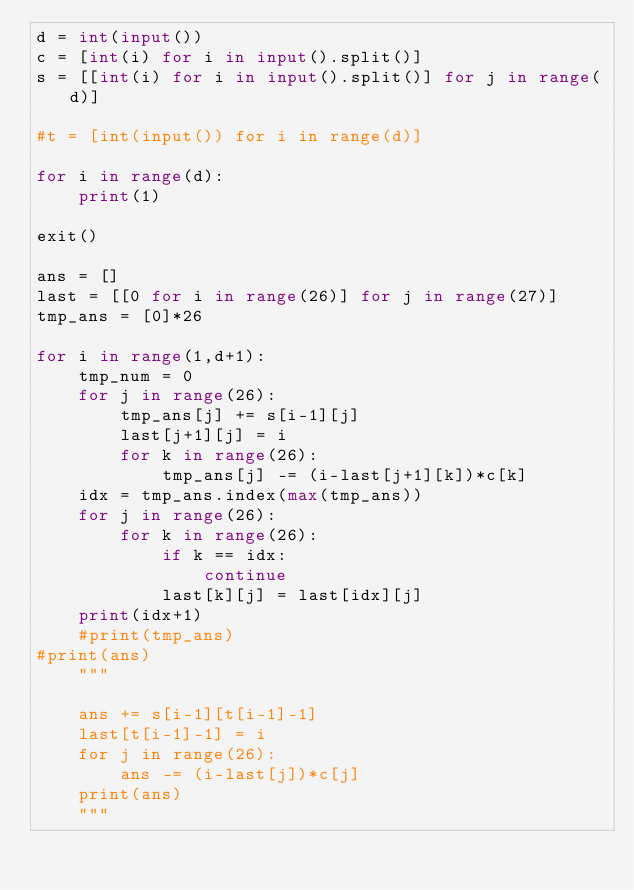<code> <loc_0><loc_0><loc_500><loc_500><_Python_>d = int(input())
c = [int(i) for i in input().split()]
s = [[int(i) for i in input().split()] for j in range(d)]

#t = [int(input()) for i in range(d)]

for i in range(d):
    print(1)
    
exit()

ans = []
last = [[0 for i in range(26)] for j in range(27)]
tmp_ans = [0]*26

for i in range(1,d+1):
    tmp_num = 0
    for j in range(26):
        tmp_ans[j] += s[i-1][j]
        last[j+1][j] = i
        for k in range(26):
            tmp_ans[j] -= (i-last[j+1][k])*c[k]
    idx = tmp_ans.index(max(tmp_ans))
    for j in range(26):
        for k in range(26):
            if k == idx:
                continue
            last[k][j] = last[idx][j]
    print(idx+1)
    #print(tmp_ans)
#print(ans)
    """
            
    ans += s[i-1][t[i-1]-1]
    last[t[i-1]-1] = i
    for j in range(26):
        ans -= (i-last[j])*c[j]
    print(ans)
    """
    
</code> 